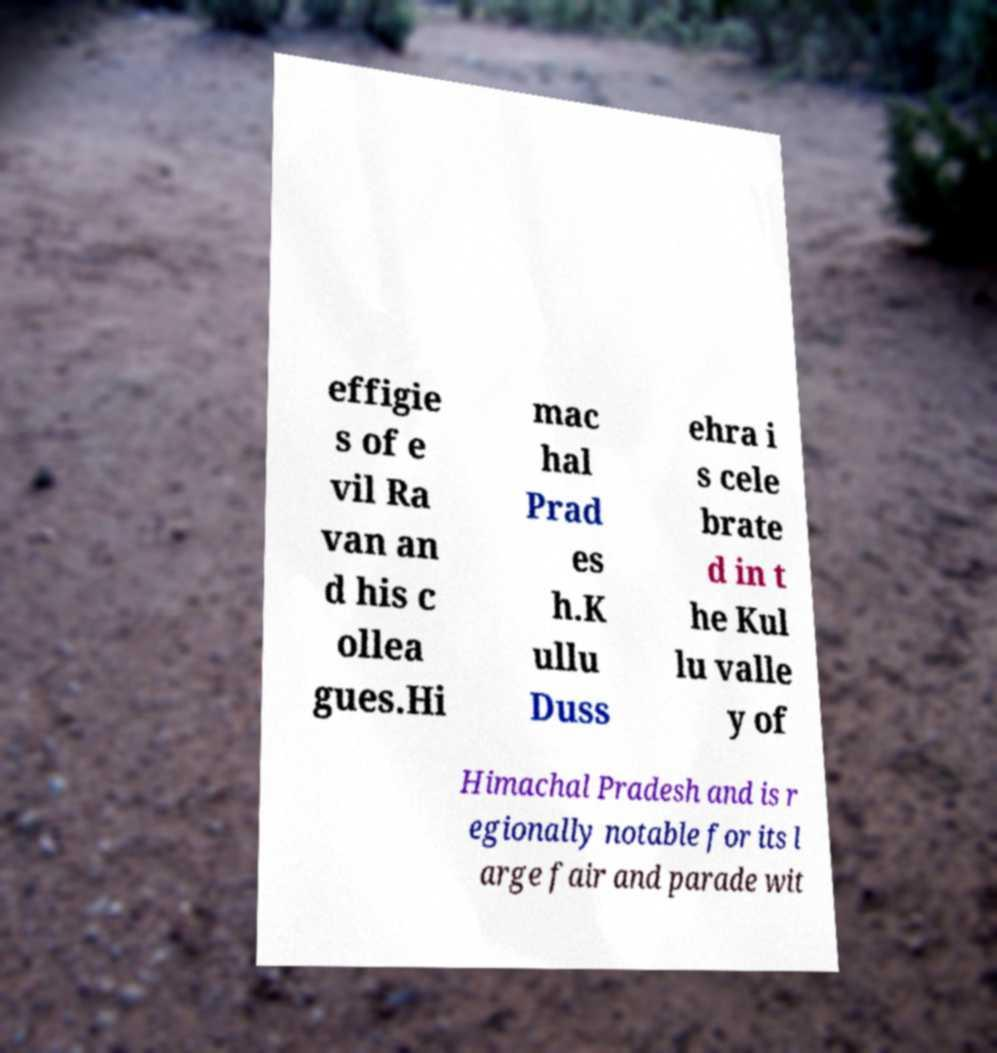Please identify and transcribe the text found in this image. effigie s of e vil Ra van an d his c ollea gues.Hi mac hal Prad es h.K ullu Duss ehra i s cele brate d in t he Kul lu valle y of Himachal Pradesh and is r egionally notable for its l arge fair and parade wit 